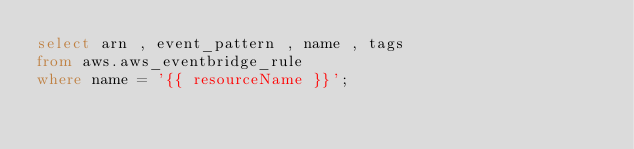Convert code to text. <code><loc_0><loc_0><loc_500><loc_500><_SQL_>select arn , event_pattern , name , tags
from aws.aws_eventbridge_rule
where name = '{{ resourceName }}';
</code> 